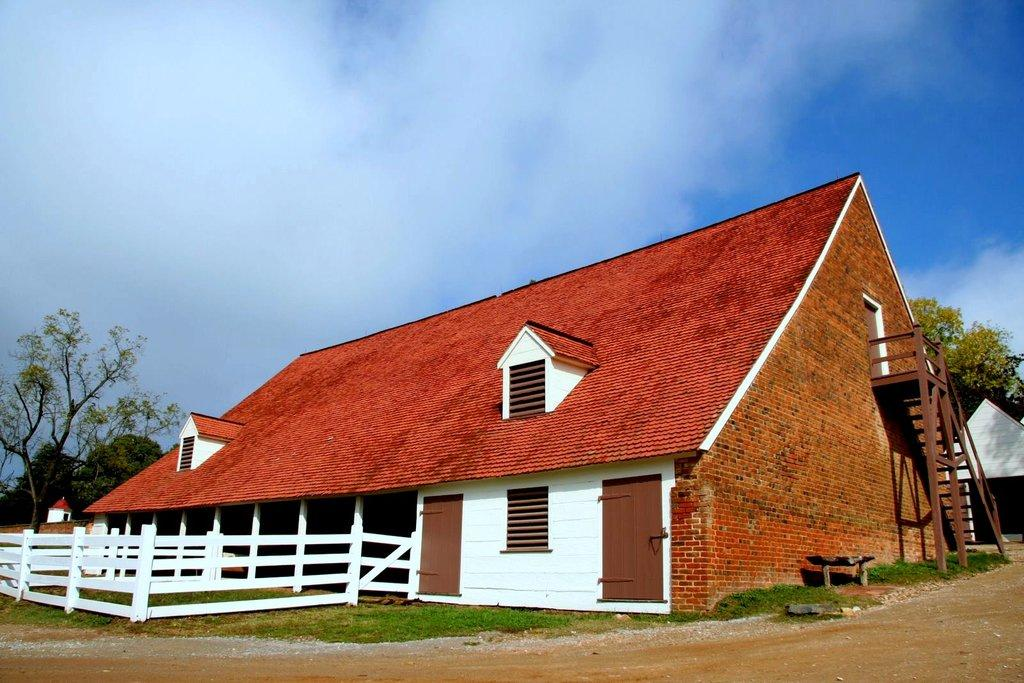What type of structure is visible in the image? There is a house in the image. What features can be seen on the house? The house has windows and doors. Can you describe any architectural elements in the image? There is a staircase in the image. What type of vegetation is present in the image? There are trees and grass in the image. What is the boundary element in the image? There is a fence in the image. What is visible in the background of the image? The sky is visible in the image. Can you hear the kitten purring quietly in the image? There is no kitten present in the image, so it cannot be heard purring quietly. 